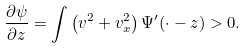Convert formula to latex. <formula><loc_0><loc_0><loc_500><loc_500>\frac { \partial \psi } { \partial z } = \int \left ( v ^ { 2 } + v _ { x } ^ { 2 } \right ) \Psi ^ { \prime } ( \cdot - z ) > 0 .</formula> 